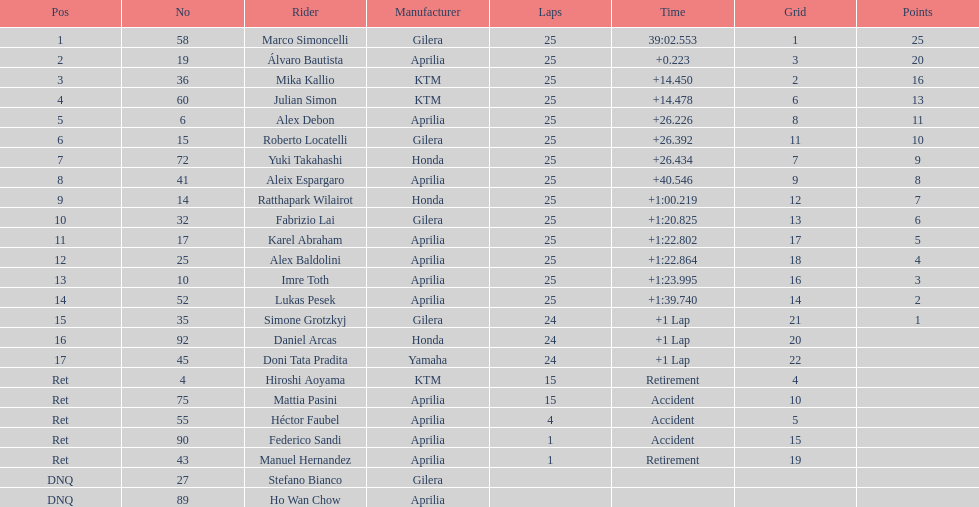Did either marco simoncelli or alvaro bautista achieve the top spot? Marco Simoncelli. 